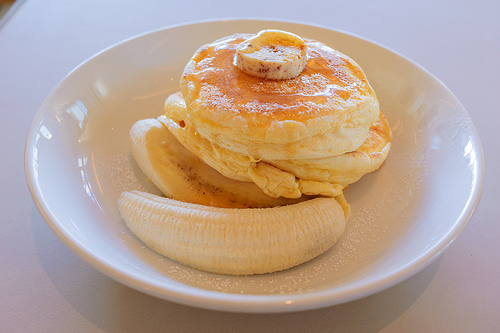<image>
Is the banana under the pancake? No. The banana is not positioned under the pancake. The vertical relationship between these objects is different. 